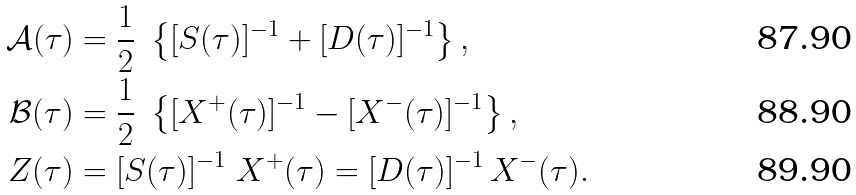Convert formula to latex. <formula><loc_0><loc_0><loc_500><loc_500>\mathcal { A } ( \tau ) & = \frac { 1 } { 2 } \ \left \{ [ S ( \tau ) ] ^ { - 1 } + [ D ( \tau ) ] ^ { - 1 } \right \} , \\ \mathcal { B } ( \tau ) & = \frac { 1 } { 2 } \ \left \{ [ X ^ { + } ( \tau ) ] ^ { - 1 } - [ X ^ { - } ( \tau ) ] ^ { - 1 } \right \} , \\ Z ( \tau ) & = [ S ( \tau ) ] ^ { - 1 } \ X ^ { + } ( \tau ) = [ D ( \tau ) ] ^ { - 1 } \, X ^ { - } ( \tau ) .</formula> 